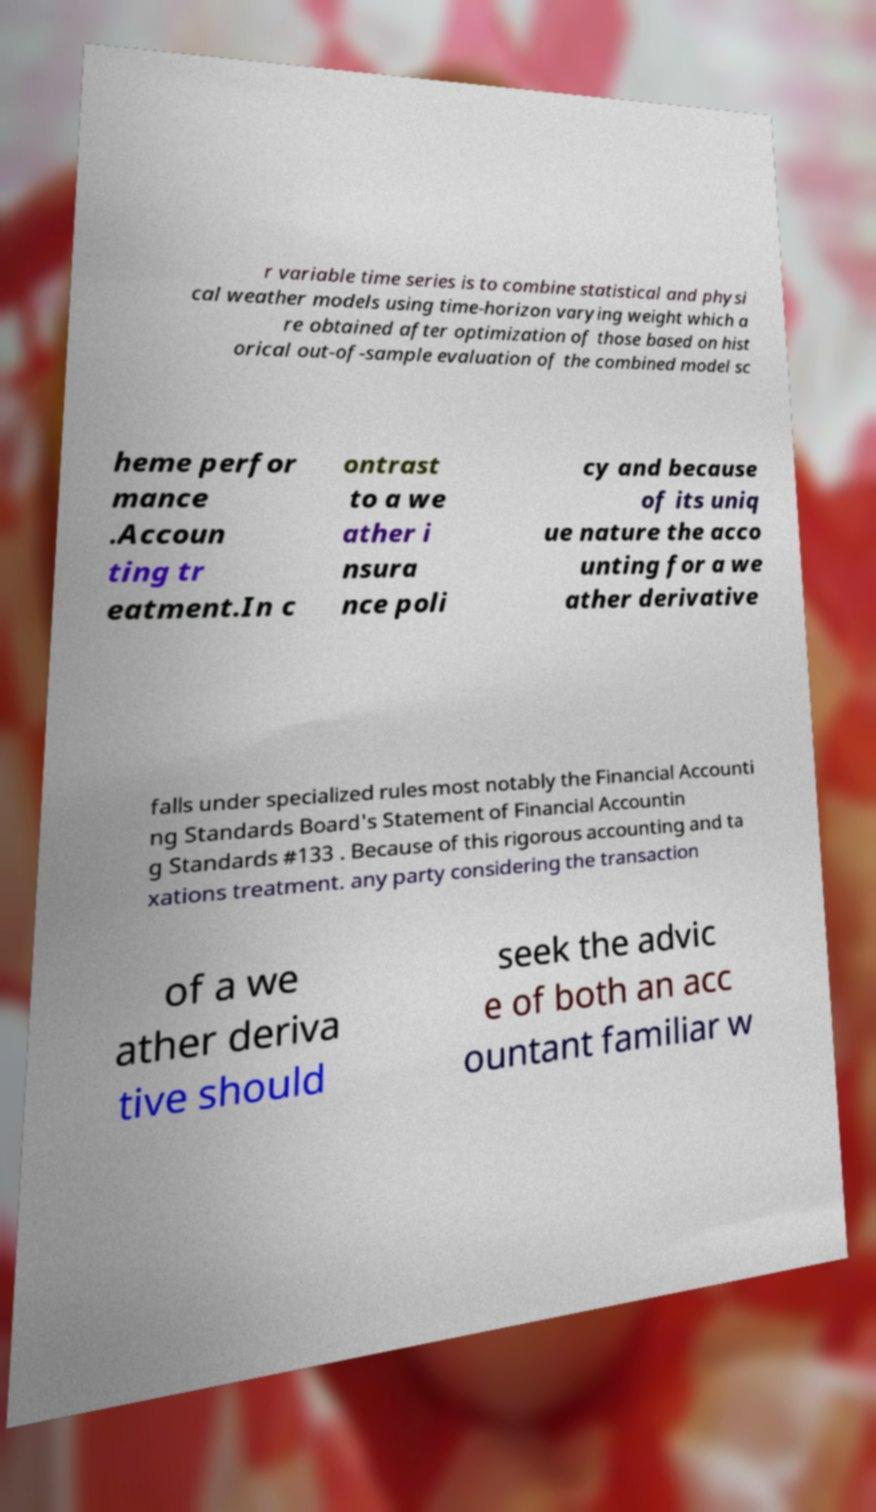What messages or text are displayed in this image? I need them in a readable, typed format. r variable time series is to combine statistical and physi cal weather models using time-horizon varying weight which a re obtained after optimization of those based on hist orical out-of-sample evaluation of the combined model sc heme perfor mance .Accoun ting tr eatment.In c ontrast to a we ather i nsura nce poli cy and because of its uniq ue nature the acco unting for a we ather derivative falls under specialized rules most notably the Financial Accounti ng Standards Board's Statement of Financial Accountin g Standards #133 . Because of this rigorous accounting and ta xations treatment. any party considering the transaction of a we ather deriva tive should seek the advic e of both an acc ountant familiar w 